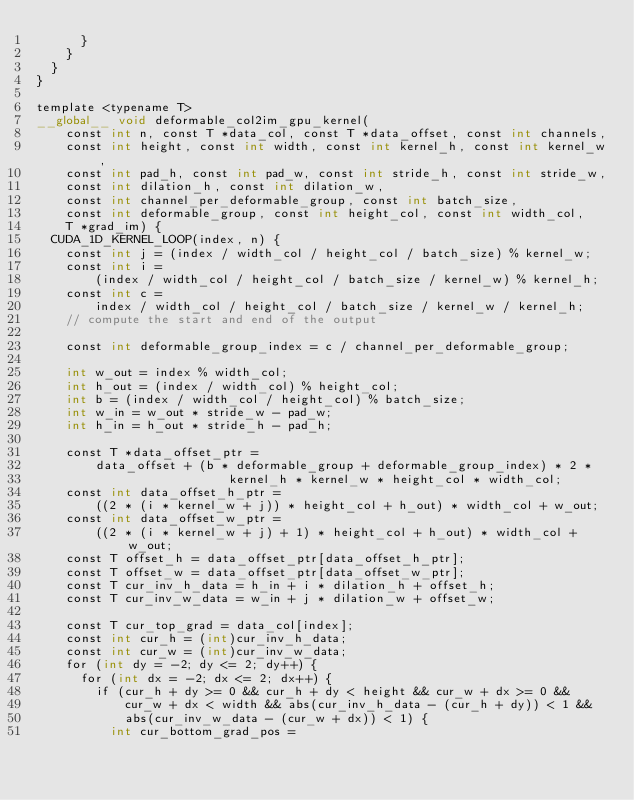Convert code to text. <code><loc_0><loc_0><loc_500><loc_500><_Cuda_>      }
    }
  }
}

template <typename T>
__global__ void deformable_col2im_gpu_kernel(
    const int n, const T *data_col, const T *data_offset, const int channels,
    const int height, const int width, const int kernel_h, const int kernel_w,
    const int pad_h, const int pad_w, const int stride_h, const int stride_w,
    const int dilation_h, const int dilation_w,
    const int channel_per_deformable_group, const int batch_size,
    const int deformable_group, const int height_col, const int width_col,
    T *grad_im) {
  CUDA_1D_KERNEL_LOOP(index, n) {
    const int j = (index / width_col / height_col / batch_size) % kernel_w;
    const int i =
        (index / width_col / height_col / batch_size / kernel_w) % kernel_h;
    const int c =
        index / width_col / height_col / batch_size / kernel_w / kernel_h;
    // compute the start and end of the output

    const int deformable_group_index = c / channel_per_deformable_group;

    int w_out = index % width_col;
    int h_out = (index / width_col) % height_col;
    int b = (index / width_col / height_col) % batch_size;
    int w_in = w_out * stride_w - pad_w;
    int h_in = h_out * stride_h - pad_h;

    const T *data_offset_ptr =
        data_offset + (b * deformable_group + deformable_group_index) * 2 *
                          kernel_h * kernel_w * height_col * width_col;
    const int data_offset_h_ptr =
        ((2 * (i * kernel_w + j)) * height_col + h_out) * width_col + w_out;
    const int data_offset_w_ptr =
        ((2 * (i * kernel_w + j) + 1) * height_col + h_out) * width_col + w_out;
    const T offset_h = data_offset_ptr[data_offset_h_ptr];
    const T offset_w = data_offset_ptr[data_offset_w_ptr];
    const T cur_inv_h_data = h_in + i * dilation_h + offset_h;
    const T cur_inv_w_data = w_in + j * dilation_w + offset_w;

    const T cur_top_grad = data_col[index];
    const int cur_h = (int)cur_inv_h_data;
    const int cur_w = (int)cur_inv_w_data;
    for (int dy = -2; dy <= 2; dy++) {
      for (int dx = -2; dx <= 2; dx++) {
        if (cur_h + dy >= 0 && cur_h + dy < height && cur_w + dx >= 0 &&
            cur_w + dx < width && abs(cur_inv_h_data - (cur_h + dy)) < 1 &&
            abs(cur_inv_w_data - (cur_w + dx)) < 1) {
          int cur_bottom_grad_pos =</code> 